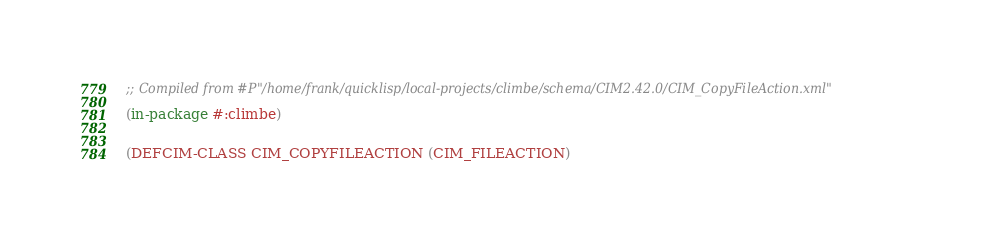<code> <loc_0><loc_0><loc_500><loc_500><_Lisp_>
;; Compiled from #P"/home/frank/quicklisp/local-projects/climbe/schema/CIM2.42.0/CIM_CopyFileAction.xml"

(in-package #:climbe)


(DEFCIM-CLASS CIM_COPYFILEACTION (CIM_FILEACTION)</code> 